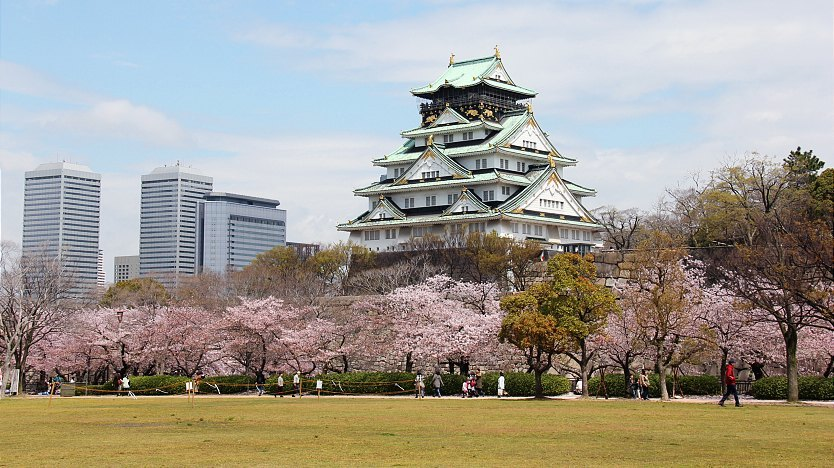What is the significance of Osaka Castle in Japanese history? Osaka Castle holds immense historical significance in Japan. It was originally built in the late 16th century by Toyotomi Hideyoshi, a prominent daimyo and military strategist, as a symbol of his power and to unify the nation. The castle played a pivotal role during the Sengoku period and the unification of Japan. Destroyed and rebuilt multiple times, the current structure was restored in the 20th century and serves as a museum, offering insights into the rich history and cultural heritage of Japan. 